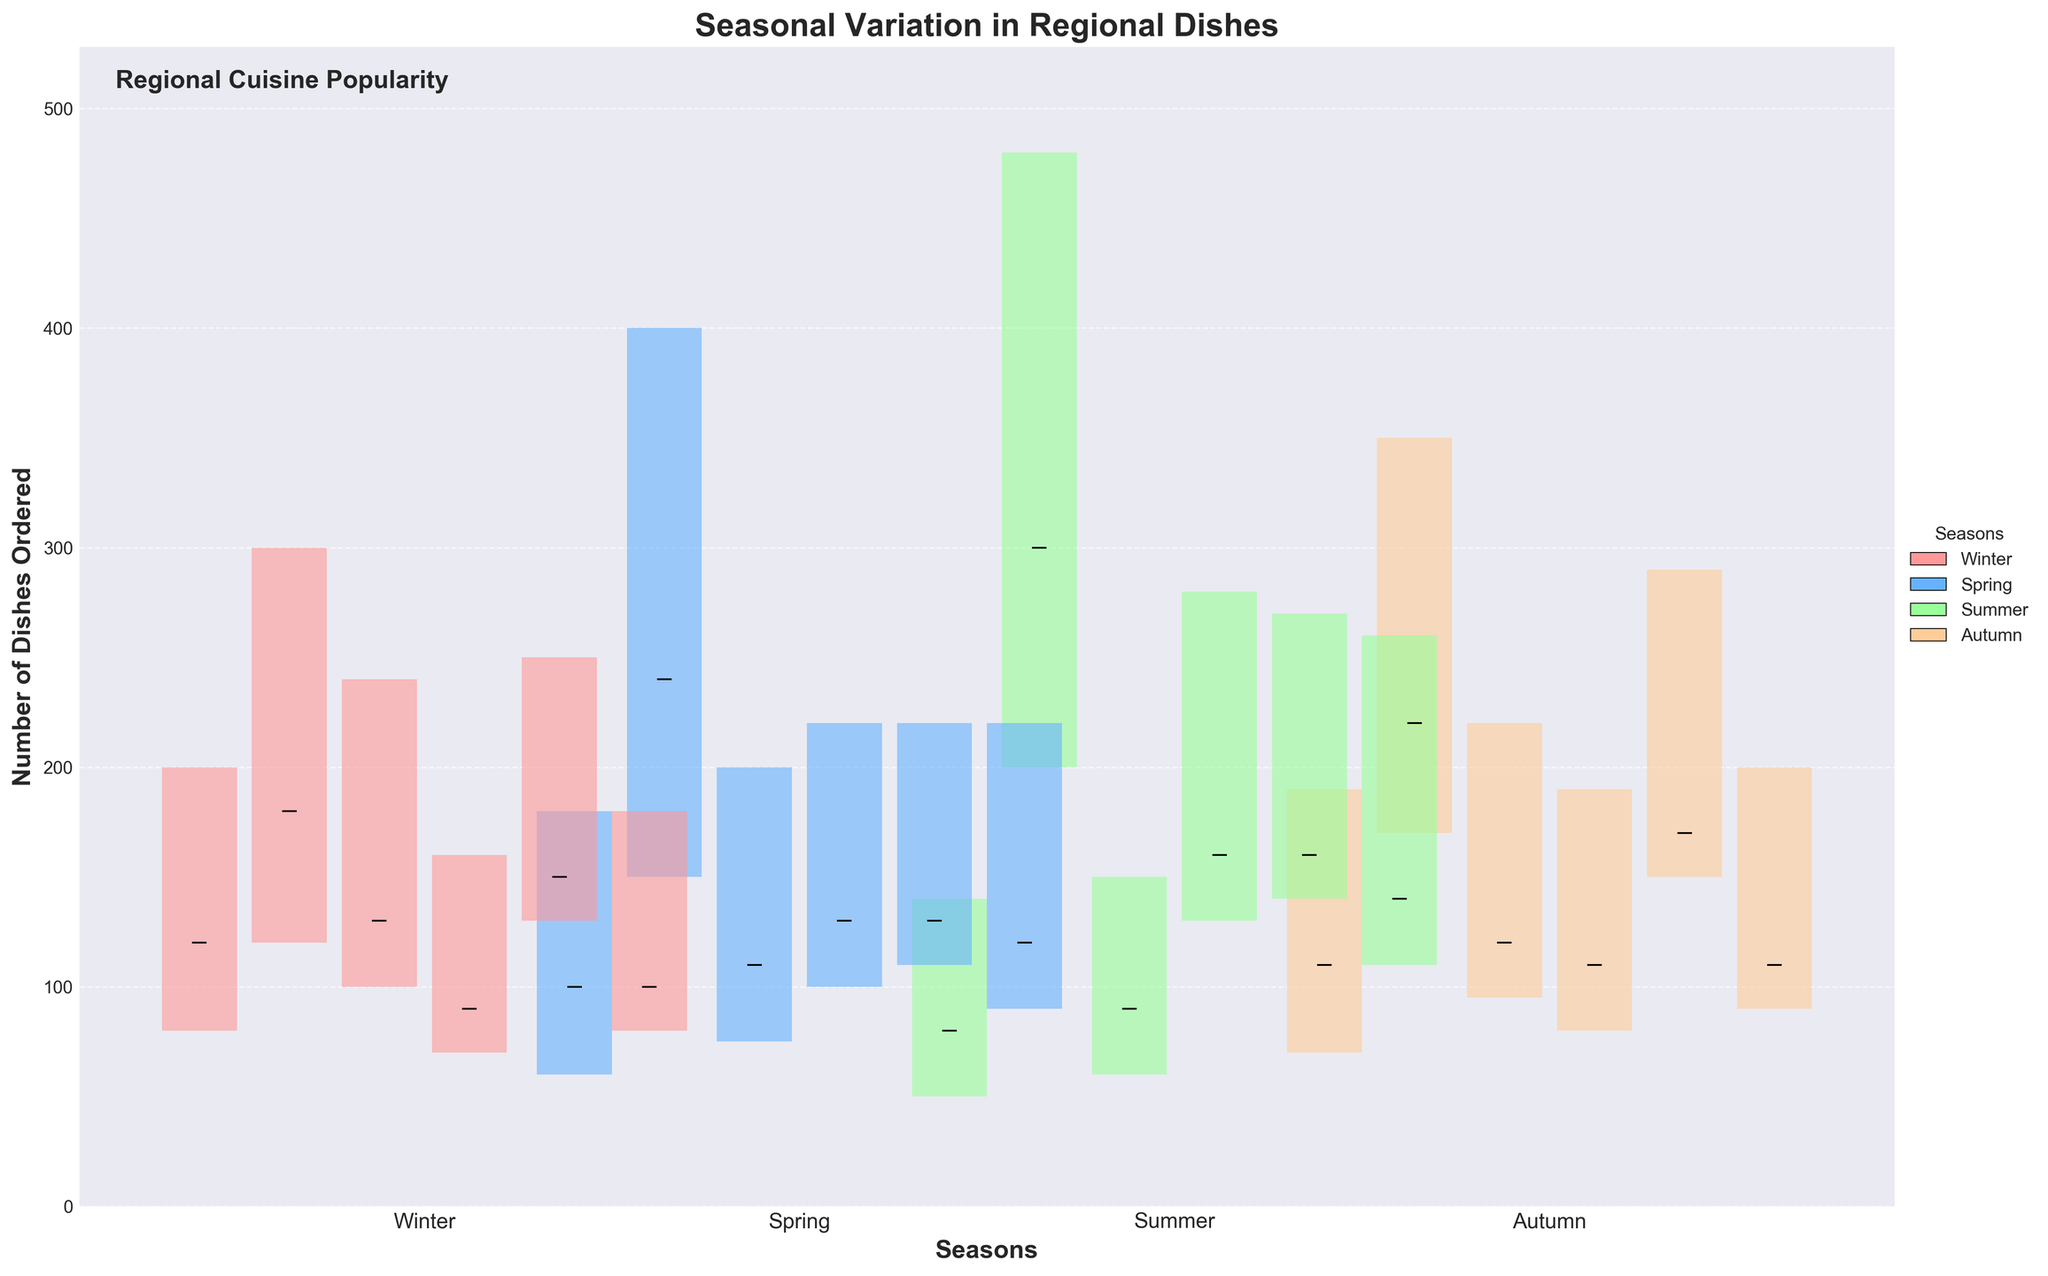What is the title of the figure? The title of the figure is prominently displayed at the top and helps identify what the plot is about.
Answer: Seasonal Variation in Regional Dishes Which season shows the highest number of BBQ Ribs ordered? Look at the bars for BBQ Ribs in each season; the highest point in the 'High' bar represents the maximum number of dishes ordered.
Answer: Summer How do the orders of Clam Chowder in Spring compare to those in Summer? For comparison, note the values for 'High' and 'Close' bars in both seasons for Clam Chowder. During Spring, the numbers are higher than in Summer.
Answer: Higher in Spring What trend can you observe in the number of Crayfish Etouffee ordered across the seasons? Observe the pattern of the 'High', 'Low', and 'Close' bars from Winter to Autumn for Crayfish Etouffee; the orders peak in Summer and decline in Autumn.
Answer: Peak in Summer, decline in Autumn How much did the orders for Apple Pie increase between Winter and Summer? Calculate the difference in the 'Close' values for Apple Pie between Winter and Summer. Winter 'Close' is 200, and Summer 'Close' is 230. The difference is 230 - 200.
Answer: 30 Which two dishes have a similar number of orders in Autumn? Identify the bars with similar 'High', 'Low', and 'Close' values for Autumn. Butternut Squash Soup and Apple Pie have similar numbers.
Answer: Butternut Squash Soup and Apple Pie Are the orders for Clam Chowder generally higher in Autumn or Spring? Compare the 'High' bars for Clam Chowder in the Spring and Autumn; observe that Autumn has a slightly higher value of 190 compared to Spring's 180.
Answer: Autumn What is the variation (range) in the number of Cioppino ordered during Summer? To find the variation, subtract the 'Low' value from the 'High' value for the Summer season of Cioppino. 'High' is 260 and 'Low' is 110.
Answer: 150 Can you identify a seasonal dish trend for Butternut Squash Soup? Observe the trend by following the 'Open', 'High', 'Low', and 'Close' bars across seasons; it peaks in Winter and Autumn, with Summer being the lowest.
Answer: Peak in Winter and Autumn, lowest in Summer Which dish shows the most stable number of orders across all seasons? Look for the dish whose bars ('High', 'Low', and 'Close') show the least variation across all seasons. Apple Pie shows relatively stable values.
Answer: Apple Pie 